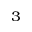Convert formula to latex. <formula><loc_0><loc_0><loc_500><loc_500>^ { 3 }</formula> 